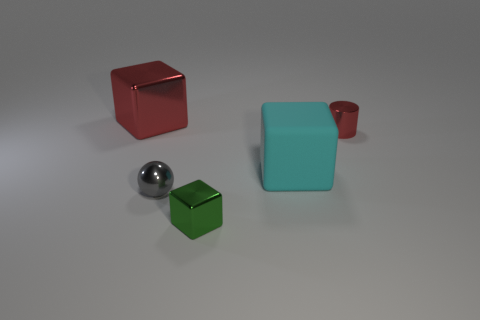Add 4 gray spheres. How many objects exist? 9 Subtract all blocks. How many objects are left? 2 Add 2 tiny things. How many tiny things are left? 5 Add 2 big balls. How many big balls exist? 2 Subtract 0 green cylinders. How many objects are left? 5 Subtract all small metal balls. Subtract all gray metallic things. How many objects are left? 3 